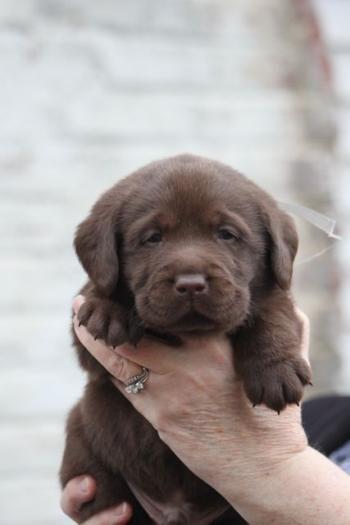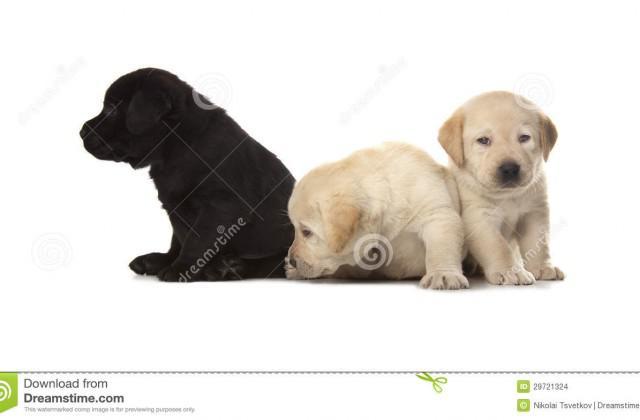The first image is the image on the left, the second image is the image on the right. Considering the images on both sides, is "There are exactly four dogs in total." valid? Answer yes or no. Yes. The first image is the image on the left, the second image is the image on the right. Assess this claim about the two images: "There are exactly four dogs.". Correct or not? Answer yes or no. Yes. 